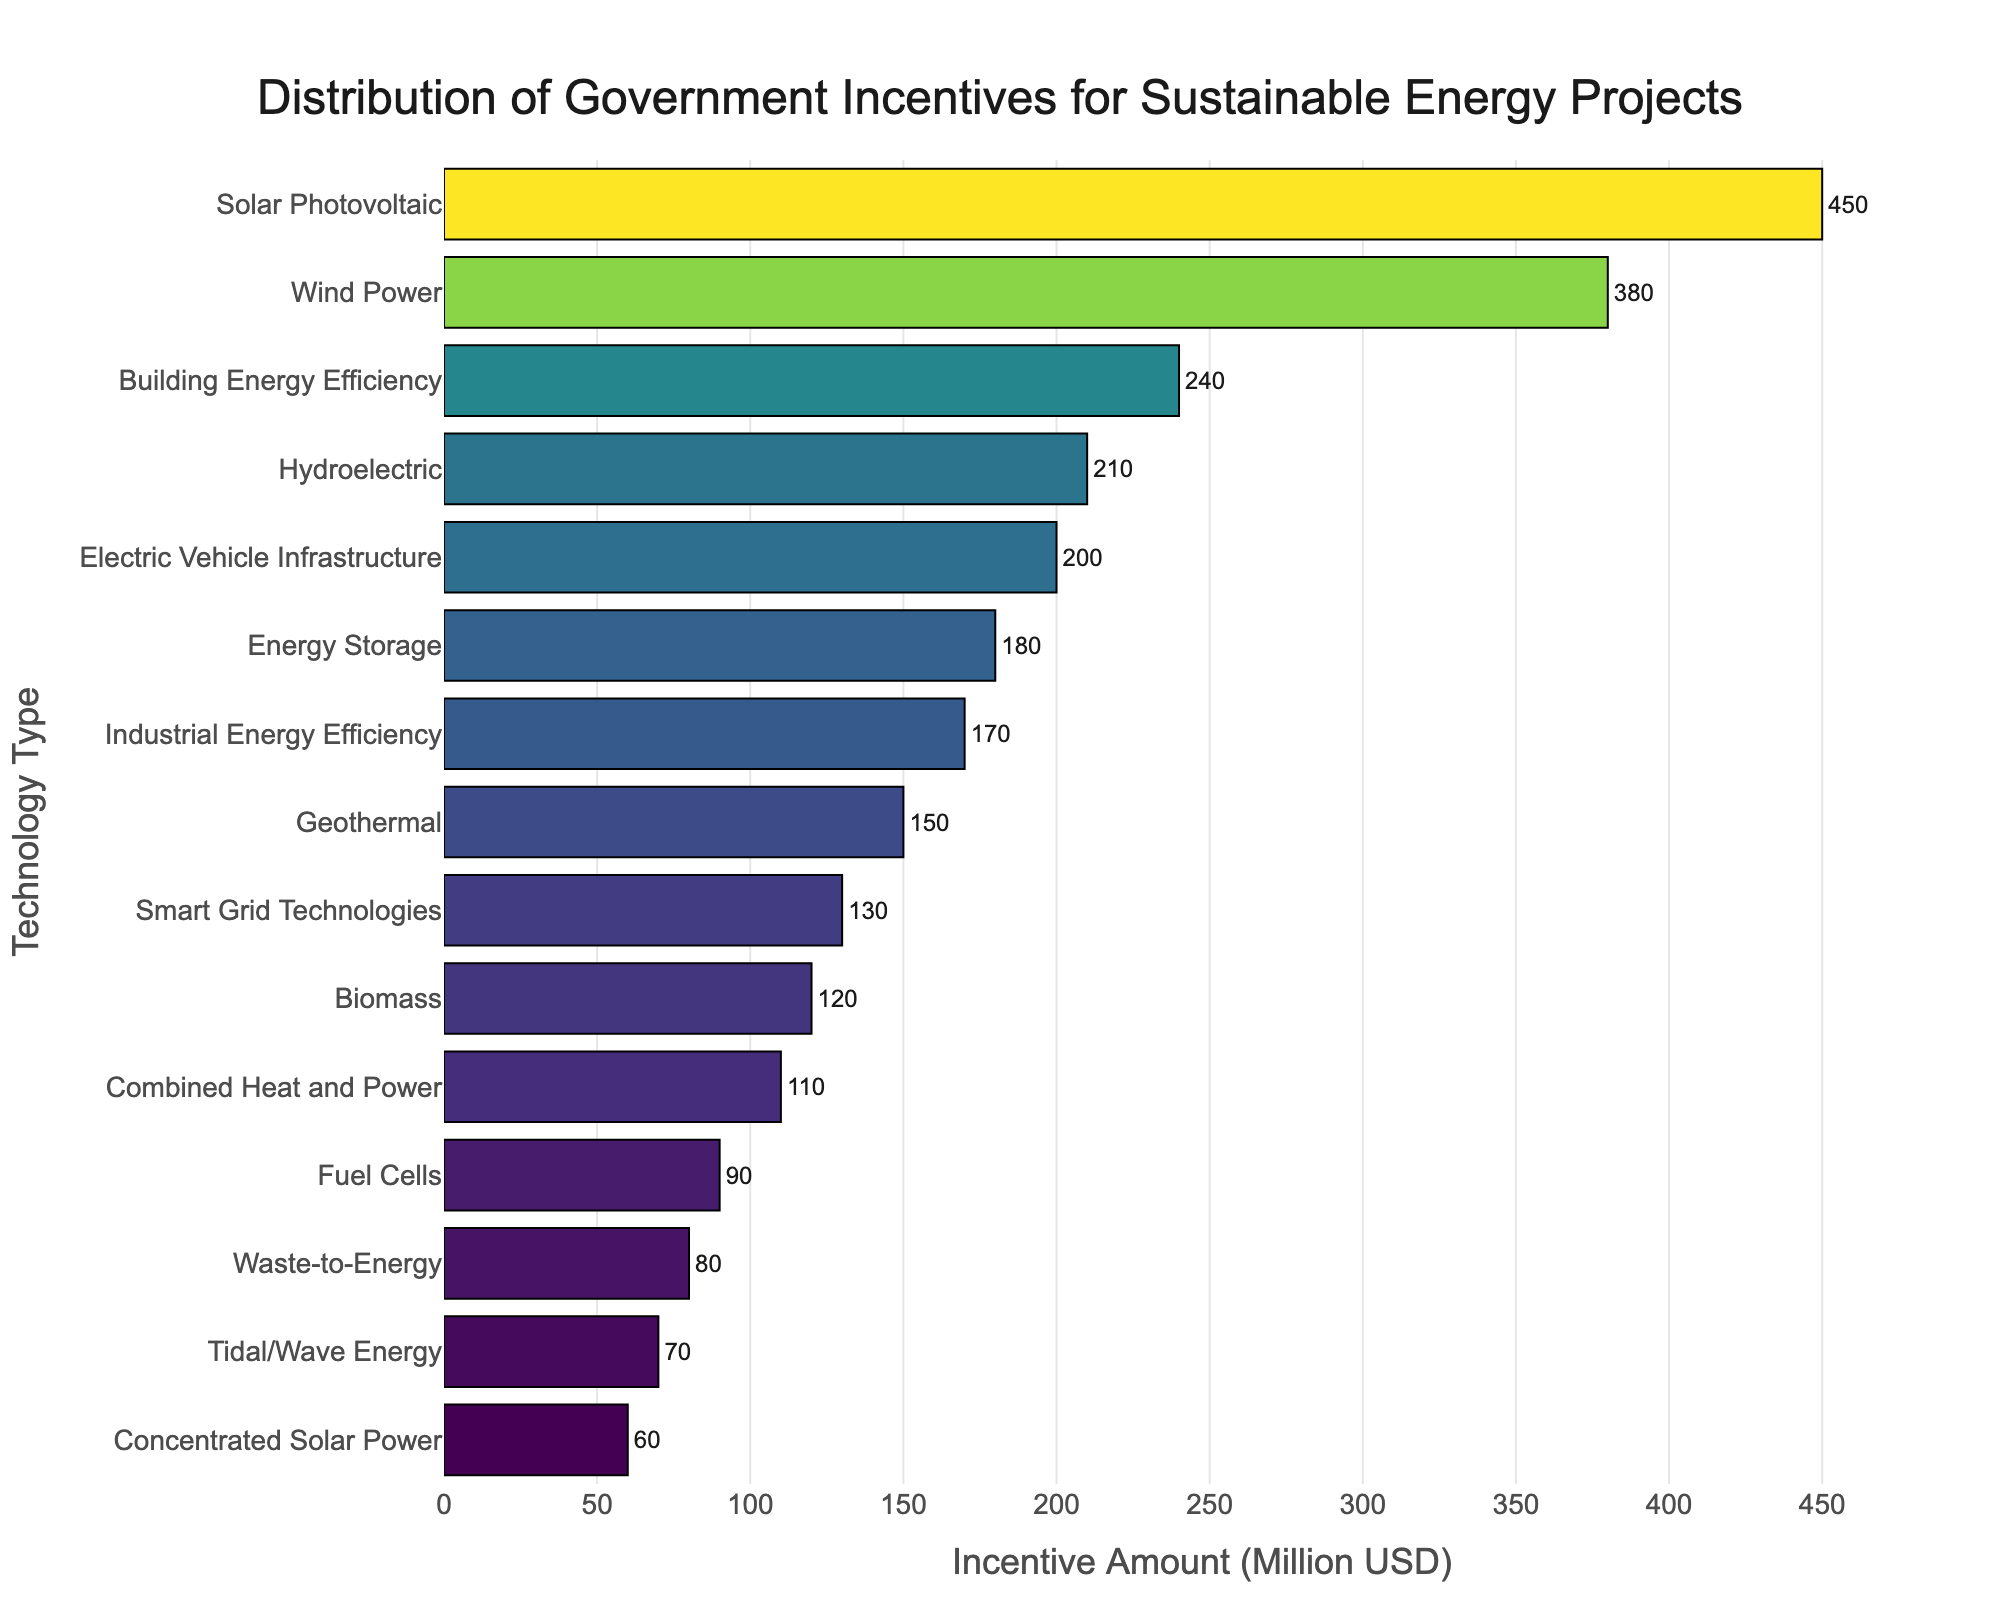How much more incentive does Solar Photovoltaic receive compared to Fuel Cells? Solar Photovoltaic receives 450 million USD and Fuel Cells receive 90 million USD. The difference is 450 - 90 = 360 million USD.
Answer: 360 million USD Which technology type received the highest amount of incentives? From the bar chart, Solar Photovoltaic received the highest amount of incentives, at 450 million USD.
Answer: Solar Photovoltaic What is the total amount of incentives given to Wind Power and Energy Storage technologies? Wind Power received 380 million USD and Energy Storage received 180 million USD. The total amount is 380 + 180 = 560 million USD.
Answer: 560 million USD How much less incentive does Tidal/Wave Energy receive compared to Building Energy Efficiency? Tidal/Wave Energy receives 70 million USD and Building Energy Efficiency receives 240 million USD. The difference is 240 - 70 = 170 million USD.
Answer: 170 million USD Which technology type receives the least amount of incentives? From the bar chart, Concentrated Solar Power receives the least amount of incentives, at 60 million USD.
Answer: Concentrated Solar Power How does the incentive amount for Electric Vehicle Infrastructure compare to Hydroelectric? Electric Vehicle Infrastructure receives 200 million USD and Hydroelectric receives 210 million USD. Electric Vehicle Infrastructure receives 10 million USD less.
Answer: 10 million USD less What is the combined total of incentives for Geothermal, Biomass, and Waste-to-Energy technologies? Geothermal receives 150 million USD, Biomass receives 120 million USD, and Waste-to-Energy receives 80 million USD. The combined total is 150 + 120 + 80 = 350 million USD.
Answer: 350 million USD What percentage of the total incentives do Smart Grid Technologies receive? First, sum all the incentives: 450 + 380 + 210 + 150 + 120 + 90 + 70 + 60 + 180 + 130 + 200 + 240 + 170 + 110 + 80 = 2640 million USD. Smart Grid Technologies receive 130 million USD. The percentage is (130 / 2640) * 100 ≈ 4.92%.
Answer: ≈ 4.92% What is the difference in incentives between Industrial Energy Efficiency and Combined Heat and Power? Industrial Energy Efficiency receives 170 million USD and Combined Heat and Power receives 110 million USD. The difference is 170 - 110 = 60 million USD.
Answer: 60 million USD Rank the top three technologies in terms of incentive amount received. The top three technologies by incentive amount are: 1) Solar Photovoltaic (450 million USD), 2) Wind Power (380 million USD), 3) Building Energy Efficiency (240 million USD).
Answer: Solar Photovoltaic, Wind Power, Building Energy Efficiency 